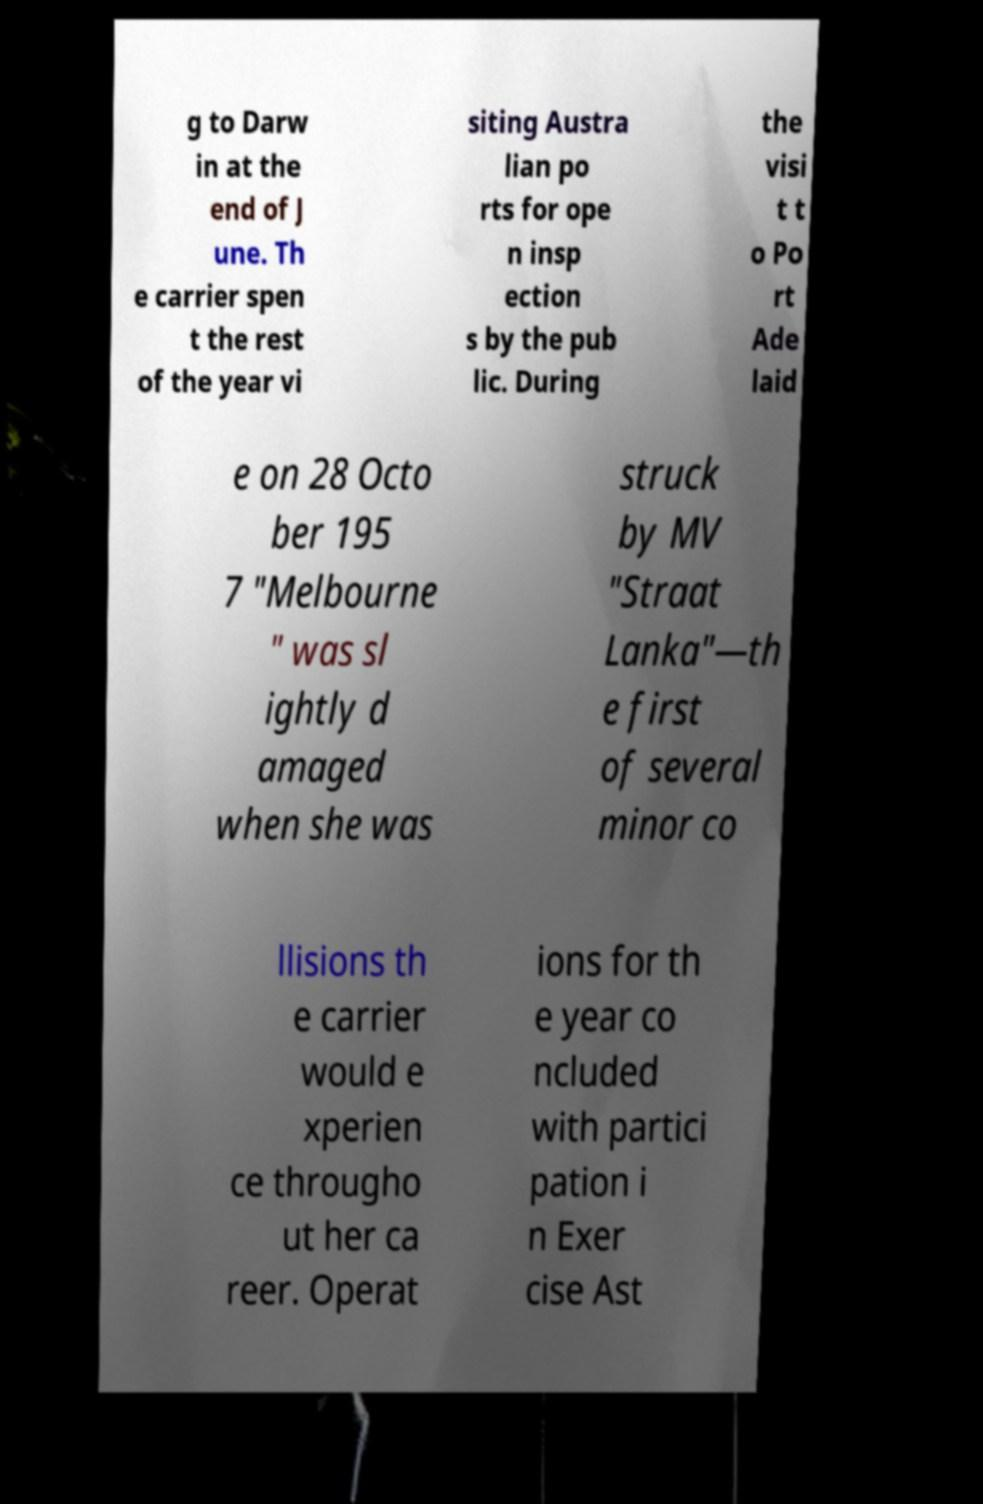Can you accurately transcribe the text from the provided image for me? g to Darw in at the end of J une. Th e carrier spen t the rest of the year vi siting Austra lian po rts for ope n insp ection s by the pub lic. During the visi t t o Po rt Ade laid e on 28 Octo ber 195 7 "Melbourne " was sl ightly d amaged when she was struck by MV "Straat Lanka"—th e first of several minor co llisions th e carrier would e xperien ce througho ut her ca reer. Operat ions for th e year co ncluded with partici pation i n Exer cise Ast 